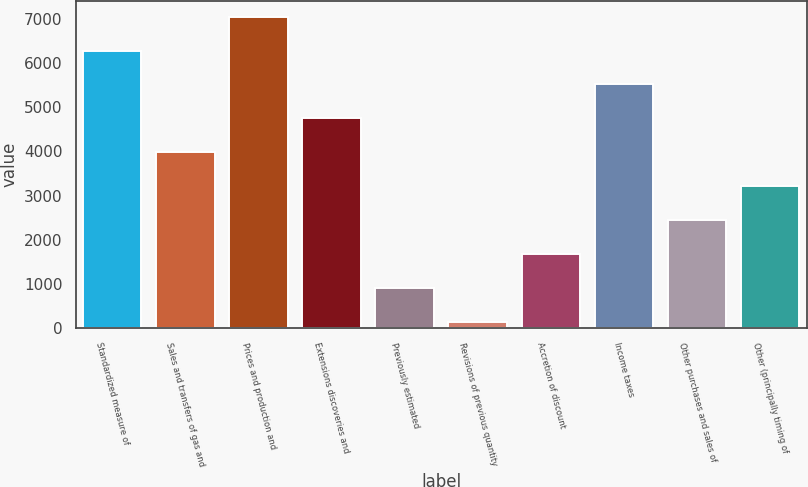<chart> <loc_0><loc_0><loc_500><loc_500><bar_chart><fcel>Standardized measure of<fcel>Sales and transfers of gas and<fcel>Prices and production and<fcel>Extensions discoveries and<fcel>Previously estimated<fcel>Revisions of previous quantity<fcel>Accretion of discount<fcel>Income taxes<fcel>Other purchases and sales of<fcel>Other (principally timing of<nl><fcel>6274.4<fcel>3978.5<fcel>7039.7<fcel>4743.8<fcel>917.3<fcel>152<fcel>1682.6<fcel>5509.1<fcel>2447.9<fcel>3213.2<nl></chart> 